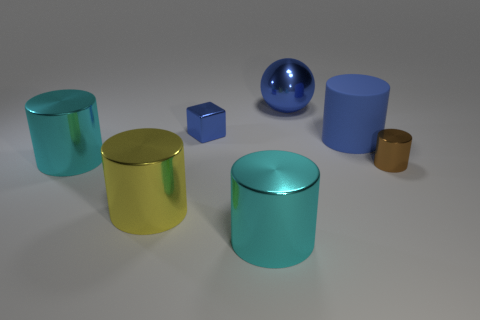Subtract all blue cylinders. How many cylinders are left? 4 Subtract all small metal cylinders. How many cylinders are left? 4 Subtract 2 cylinders. How many cylinders are left? 3 Subtract all purple cylinders. Subtract all yellow cubes. How many cylinders are left? 5 Add 3 cyan things. How many objects exist? 10 Subtract all cubes. How many objects are left? 6 Add 6 shiny cylinders. How many shiny cylinders are left? 10 Add 5 large cyan metallic cylinders. How many large cyan metallic cylinders exist? 7 Subtract 0 green cubes. How many objects are left? 7 Subtract all cyan cylinders. Subtract all large objects. How many objects are left? 0 